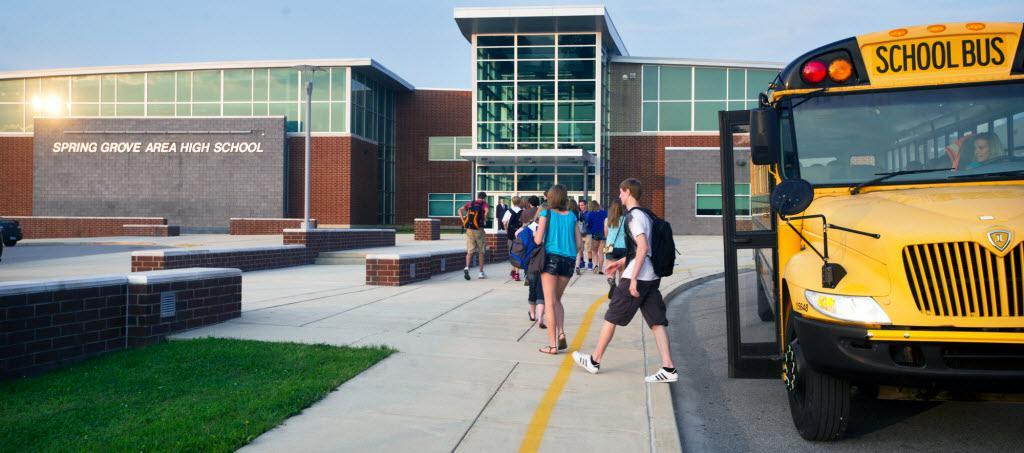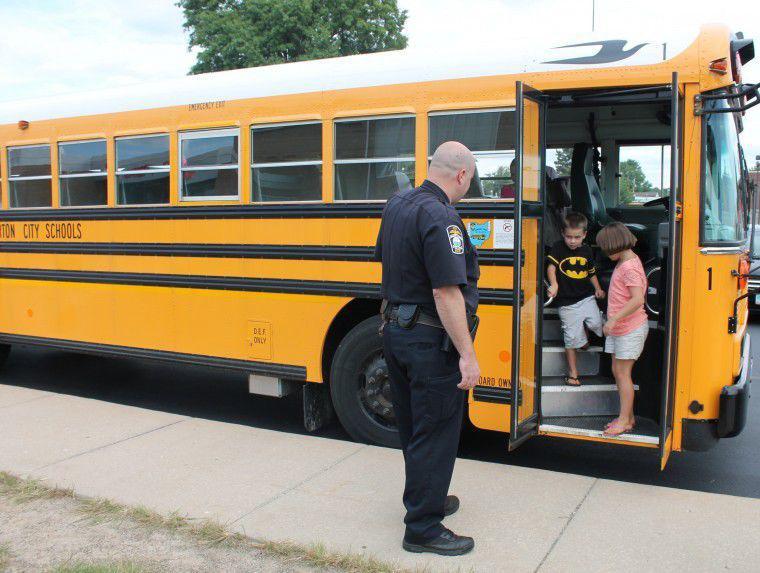The first image is the image on the left, the second image is the image on the right. Examine the images to the left and right. Is the description "An officer stands outside of the bus in the image on the right." accurate? Answer yes or no. Yes. The first image is the image on the left, the second image is the image on the right. Considering the images on both sides, is "The right image includes at least one adult and at least two young children by the open doors of a bus parked diagonally facing right, and the left image shows at least two teens with backpacks to the left of a bus with an open door." valid? Answer yes or no. Yes. 